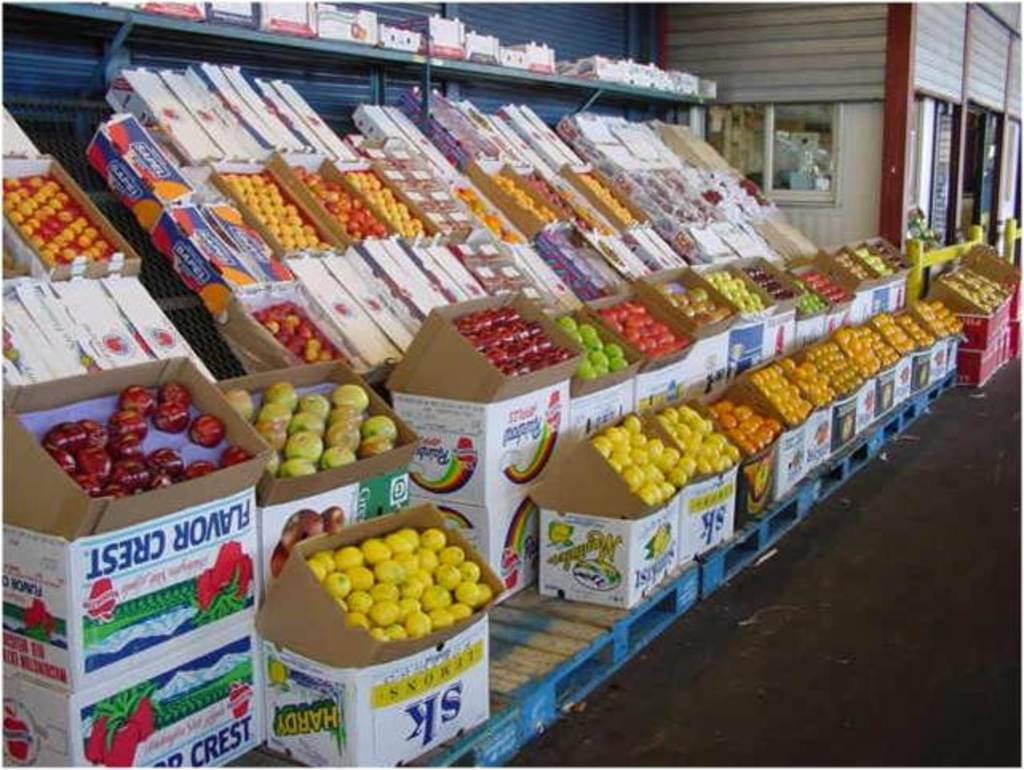What type of food can be seen in the image? There are fruits in the image. What is visible in the background of the image? There is a building behind the fruits in the image. What type of juice is being squeezed from the fruits in the image? There is no juice being squeezed from the fruits in the image; it only shows the fruits themselves. Can you see an army marching in the image? There is no army or any indication of military presence in the image. 